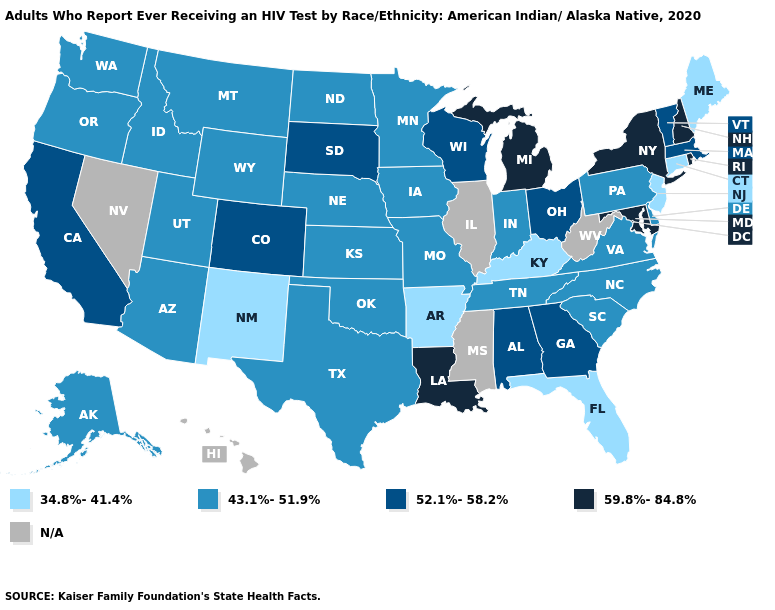Name the states that have a value in the range 59.8%-84.8%?
Short answer required. Louisiana, Maryland, Michigan, New Hampshire, New York, Rhode Island. Which states have the lowest value in the USA?
Be succinct. Arkansas, Connecticut, Florida, Kentucky, Maine, New Jersey, New Mexico. Does the map have missing data?
Quick response, please. Yes. Does the map have missing data?
Write a very short answer. Yes. Name the states that have a value in the range 34.8%-41.4%?
Write a very short answer. Arkansas, Connecticut, Florida, Kentucky, Maine, New Jersey, New Mexico. Among the states that border North Dakota , does Minnesota have the lowest value?
Keep it brief. Yes. Name the states that have a value in the range N/A?
Answer briefly. Hawaii, Illinois, Mississippi, Nevada, West Virginia. Is the legend a continuous bar?
Give a very brief answer. No. What is the value of Virginia?
Quick response, please. 43.1%-51.9%. Among the states that border Nevada , which have the highest value?
Write a very short answer. California. What is the lowest value in the USA?
Quick response, please. 34.8%-41.4%. Name the states that have a value in the range N/A?
Short answer required. Hawaii, Illinois, Mississippi, Nevada, West Virginia. Does the map have missing data?
Give a very brief answer. Yes. What is the value of North Dakota?
Short answer required. 43.1%-51.9%. 